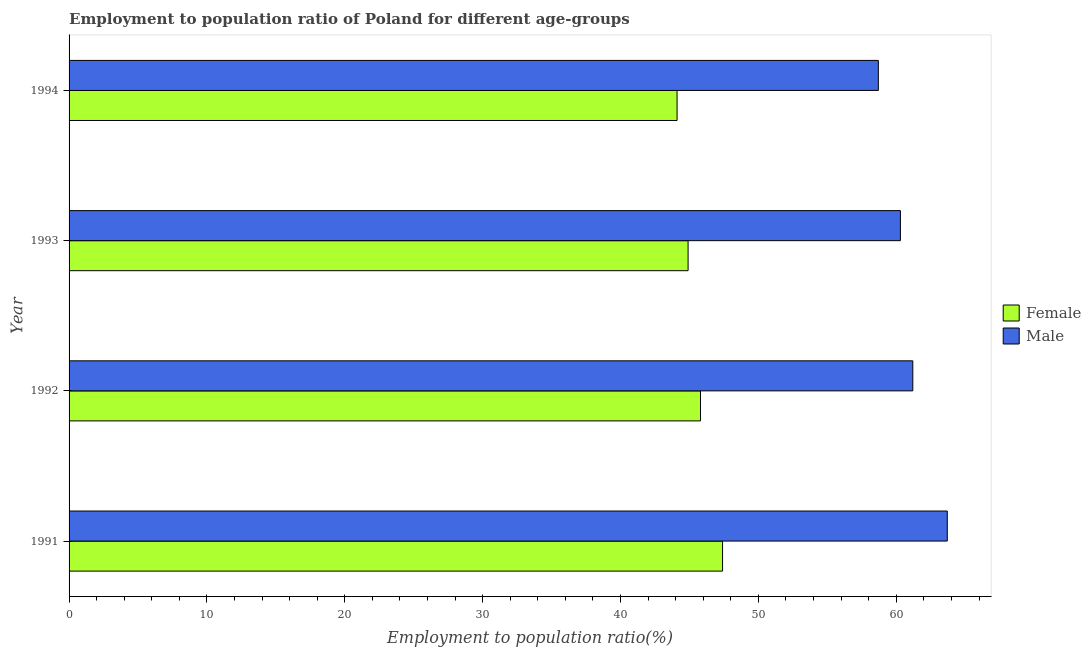How many different coloured bars are there?
Offer a terse response. 2. How many bars are there on the 3rd tick from the top?
Provide a short and direct response. 2. In how many cases, is the number of bars for a given year not equal to the number of legend labels?
Make the answer very short. 0. What is the employment to population ratio(female) in 1992?
Give a very brief answer. 45.8. Across all years, what is the maximum employment to population ratio(male)?
Your answer should be very brief. 63.7. Across all years, what is the minimum employment to population ratio(female)?
Provide a succinct answer. 44.1. In which year was the employment to population ratio(female) minimum?
Make the answer very short. 1994. What is the total employment to population ratio(male) in the graph?
Your answer should be very brief. 243.9. What is the difference between the employment to population ratio(male) in 1994 and the employment to population ratio(female) in 1993?
Give a very brief answer. 13.8. What is the average employment to population ratio(male) per year?
Provide a succinct answer. 60.98. In how many years, is the employment to population ratio(male) greater than 24 %?
Make the answer very short. 4. What is the ratio of the employment to population ratio(male) in 1993 to that in 1994?
Offer a very short reply. 1.03. Is the difference between the employment to population ratio(female) in 1992 and 1993 greater than the difference between the employment to population ratio(male) in 1992 and 1993?
Make the answer very short. No. In how many years, is the employment to population ratio(female) greater than the average employment to population ratio(female) taken over all years?
Offer a very short reply. 2. What does the 2nd bar from the top in 1992 represents?
Provide a short and direct response. Female. Are all the bars in the graph horizontal?
Your answer should be very brief. Yes. Does the graph contain grids?
Offer a terse response. No. Where does the legend appear in the graph?
Keep it short and to the point. Center right. What is the title of the graph?
Give a very brief answer. Employment to population ratio of Poland for different age-groups. What is the label or title of the X-axis?
Make the answer very short. Employment to population ratio(%). What is the Employment to population ratio(%) in Female in 1991?
Offer a very short reply. 47.4. What is the Employment to population ratio(%) of Male in 1991?
Your answer should be compact. 63.7. What is the Employment to population ratio(%) in Female in 1992?
Ensure brevity in your answer.  45.8. What is the Employment to population ratio(%) in Male in 1992?
Your response must be concise. 61.2. What is the Employment to population ratio(%) of Female in 1993?
Make the answer very short. 44.9. What is the Employment to population ratio(%) of Male in 1993?
Give a very brief answer. 60.3. What is the Employment to population ratio(%) in Female in 1994?
Make the answer very short. 44.1. What is the Employment to population ratio(%) in Male in 1994?
Make the answer very short. 58.7. Across all years, what is the maximum Employment to population ratio(%) in Female?
Give a very brief answer. 47.4. Across all years, what is the maximum Employment to population ratio(%) of Male?
Your answer should be very brief. 63.7. Across all years, what is the minimum Employment to population ratio(%) of Female?
Your response must be concise. 44.1. Across all years, what is the minimum Employment to population ratio(%) in Male?
Provide a short and direct response. 58.7. What is the total Employment to population ratio(%) in Female in the graph?
Provide a succinct answer. 182.2. What is the total Employment to population ratio(%) of Male in the graph?
Your response must be concise. 243.9. What is the difference between the Employment to population ratio(%) of Male in 1991 and that in 1992?
Keep it short and to the point. 2.5. What is the difference between the Employment to population ratio(%) in Female in 1991 and that in 1993?
Your answer should be compact. 2.5. What is the difference between the Employment to population ratio(%) of Female in 1992 and that in 1993?
Offer a terse response. 0.9. What is the difference between the Employment to population ratio(%) in Female in 1992 and that in 1994?
Offer a very short reply. 1.7. What is the difference between the Employment to population ratio(%) of Male in 1992 and that in 1994?
Keep it short and to the point. 2.5. What is the difference between the Employment to population ratio(%) in Male in 1993 and that in 1994?
Provide a succinct answer. 1.6. What is the difference between the Employment to population ratio(%) in Female in 1991 and the Employment to population ratio(%) in Male in 1993?
Your answer should be very brief. -12.9. What is the difference between the Employment to population ratio(%) of Female in 1991 and the Employment to population ratio(%) of Male in 1994?
Your answer should be compact. -11.3. What is the difference between the Employment to population ratio(%) in Female in 1992 and the Employment to population ratio(%) in Male in 1993?
Your response must be concise. -14.5. What is the average Employment to population ratio(%) of Female per year?
Ensure brevity in your answer.  45.55. What is the average Employment to population ratio(%) in Male per year?
Your response must be concise. 60.98. In the year 1991, what is the difference between the Employment to population ratio(%) in Female and Employment to population ratio(%) in Male?
Ensure brevity in your answer.  -16.3. In the year 1992, what is the difference between the Employment to population ratio(%) in Female and Employment to population ratio(%) in Male?
Offer a very short reply. -15.4. In the year 1993, what is the difference between the Employment to population ratio(%) in Female and Employment to population ratio(%) in Male?
Offer a very short reply. -15.4. In the year 1994, what is the difference between the Employment to population ratio(%) of Female and Employment to population ratio(%) of Male?
Provide a succinct answer. -14.6. What is the ratio of the Employment to population ratio(%) of Female in 1991 to that in 1992?
Give a very brief answer. 1.03. What is the ratio of the Employment to population ratio(%) of Male in 1991 to that in 1992?
Offer a terse response. 1.04. What is the ratio of the Employment to population ratio(%) of Female in 1991 to that in 1993?
Your response must be concise. 1.06. What is the ratio of the Employment to population ratio(%) in Male in 1991 to that in 1993?
Make the answer very short. 1.06. What is the ratio of the Employment to population ratio(%) of Female in 1991 to that in 1994?
Make the answer very short. 1.07. What is the ratio of the Employment to population ratio(%) of Male in 1991 to that in 1994?
Ensure brevity in your answer.  1.09. What is the ratio of the Employment to population ratio(%) in Male in 1992 to that in 1993?
Offer a very short reply. 1.01. What is the ratio of the Employment to population ratio(%) in Female in 1992 to that in 1994?
Give a very brief answer. 1.04. What is the ratio of the Employment to population ratio(%) of Male in 1992 to that in 1994?
Your answer should be compact. 1.04. What is the ratio of the Employment to population ratio(%) in Female in 1993 to that in 1994?
Your answer should be very brief. 1.02. What is the ratio of the Employment to population ratio(%) of Male in 1993 to that in 1994?
Your answer should be compact. 1.03. What is the difference between the highest and the second highest Employment to population ratio(%) of Female?
Offer a terse response. 1.6. What is the difference between the highest and the second highest Employment to population ratio(%) in Male?
Provide a succinct answer. 2.5. 